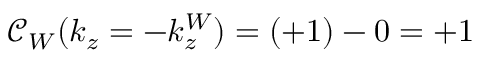Convert formula to latex. <formula><loc_0><loc_0><loc_500><loc_500>\mathcal { C } _ { W } ( k _ { z } = - k _ { z } ^ { W } ) = ( + 1 ) - 0 = + 1</formula> 